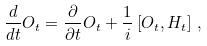<formula> <loc_0><loc_0><loc_500><loc_500>\frac { d } { d t } O _ { t } = \frac { \partial } { \partial t } O _ { t } + \frac { 1 } { i } \left [ O _ { t } , H _ { t } \right ] \, ,</formula> 